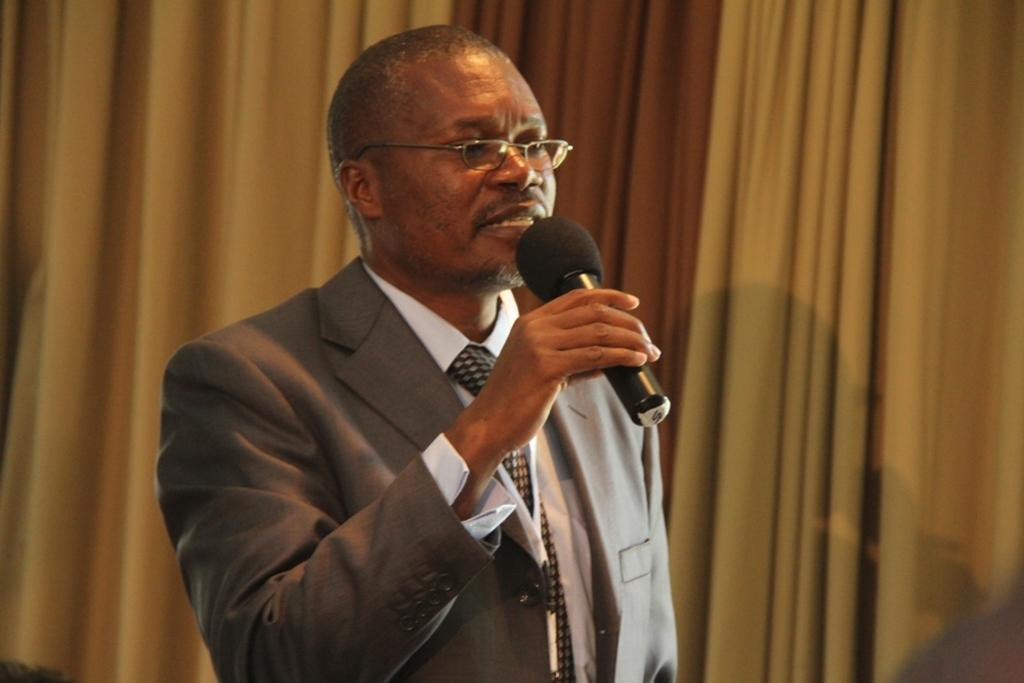What is the man in the image wearing? The man is wearing a grey jacket and a white shirt. What is the man holding in his hand? The man is holding a mic in his hand. What is the man doing in the image? The man is talking. What accessory is the man wearing on his face? The man is wearing spectacles. What can be seen in the background of the image? There is a curtain in the background of the image. Can you tell me how many crayons the man is holding in the image? There are no crayons present in the image; the man is holding a mic. 